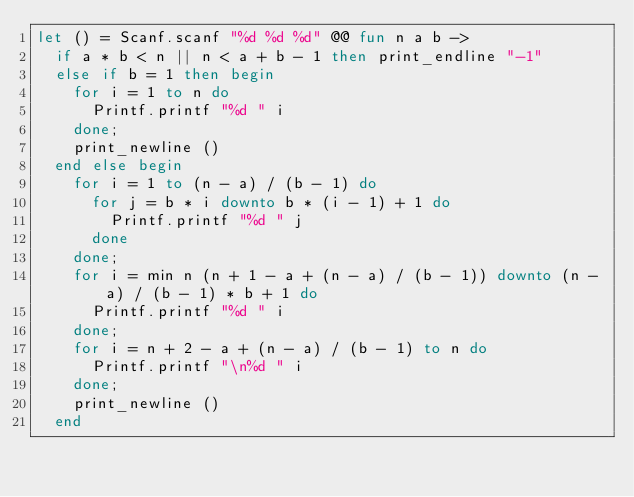Convert code to text. <code><loc_0><loc_0><loc_500><loc_500><_OCaml_>let () = Scanf.scanf "%d %d %d" @@ fun n a b ->
  if a * b < n || n < a + b - 1 then print_endline "-1"
  else if b = 1 then begin
    for i = 1 to n do
      Printf.printf "%d " i
    done;
    print_newline ()
  end else begin
    for i = 1 to (n - a) / (b - 1) do
      for j = b * i downto b * (i - 1) + 1 do
        Printf.printf "%d " j
      done
    done;
    for i = min n (n + 1 - a + (n - a) / (b - 1)) downto (n - a) / (b - 1) * b + 1 do
      Printf.printf "%d " i
    done;
    for i = n + 2 - a + (n - a) / (b - 1) to n do
      Printf.printf "\n%d " i
    done;
    print_newline ()
  end
</code> 